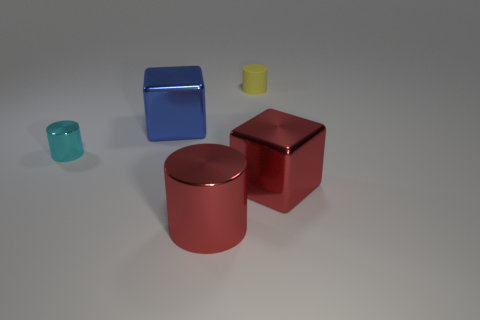Do the big red object that is right of the rubber object and the big cylinder have the same material? Yes, the big red object to the right of the small semi-transparent rubbery looking object and the large cylinder appear to be made of similar materials, both exhibiting a reflective metallic surface and sharing a similar sheen indicating they could be made of the same or similar types of metal. 